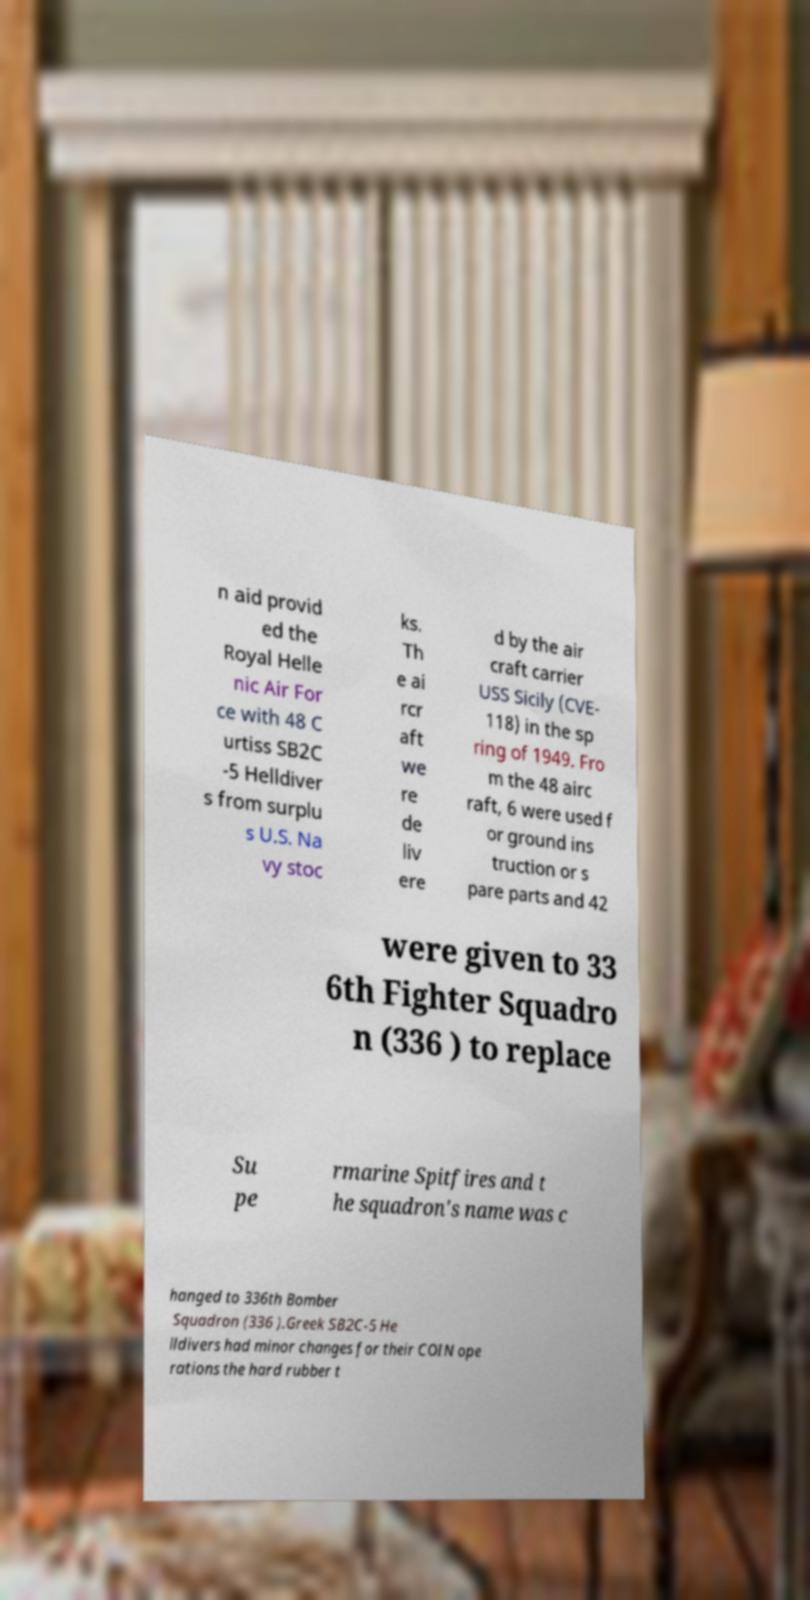Can you read and provide the text displayed in the image?This photo seems to have some interesting text. Can you extract and type it out for me? n aid provid ed the Royal Helle nic Air For ce with 48 C urtiss SB2C -5 Helldiver s from surplu s U.S. Na vy stoc ks. Th e ai rcr aft we re de liv ere d by the air craft carrier USS Sicily (CVE- 118) in the sp ring of 1949. Fro m the 48 airc raft, 6 were used f or ground ins truction or s pare parts and 42 were given to 33 6th Fighter Squadro n (336 ) to replace Su pe rmarine Spitfires and t he squadron's name was c hanged to 336th Bomber Squadron (336 ).Greek SB2C-5 He lldivers had minor changes for their COIN ope rations the hard rubber t 